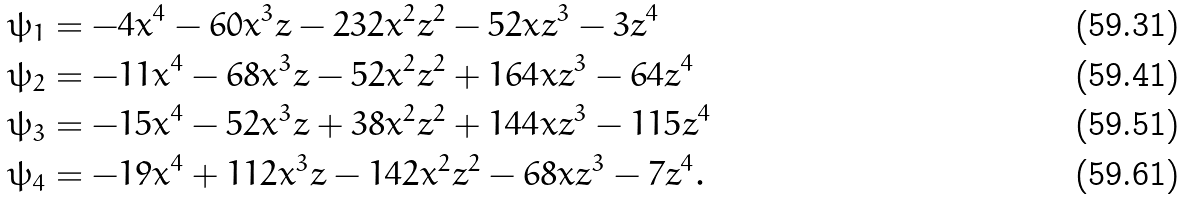<formula> <loc_0><loc_0><loc_500><loc_500>\psi _ { 1 } & = - 4 x ^ { 4 } - 6 0 x ^ { 3 } z - 2 3 2 x ^ { 2 } z ^ { 2 } - 5 2 x z ^ { 3 } - 3 z ^ { 4 } \\ \psi _ { 2 } & = - 1 1 x ^ { 4 } - 6 8 x ^ { 3 } z - 5 2 x ^ { 2 } z ^ { 2 } + 1 6 4 x z ^ { 3 } - 6 4 z ^ { 4 } \\ \psi _ { 3 } & = - 1 5 x ^ { 4 } - 5 2 x ^ { 3 } z + 3 8 x ^ { 2 } z ^ { 2 } + 1 4 4 x z ^ { 3 } - 1 1 5 z ^ { 4 } \\ \psi _ { 4 } & = - 1 9 x ^ { 4 } + 1 1 2 x ^ { 3 } z - 1 4 2 x ^ { 2 } z ^ { 2 } - 6 8 x z ^ { 3 } - 7 z ^ { 4 } .</formula> 